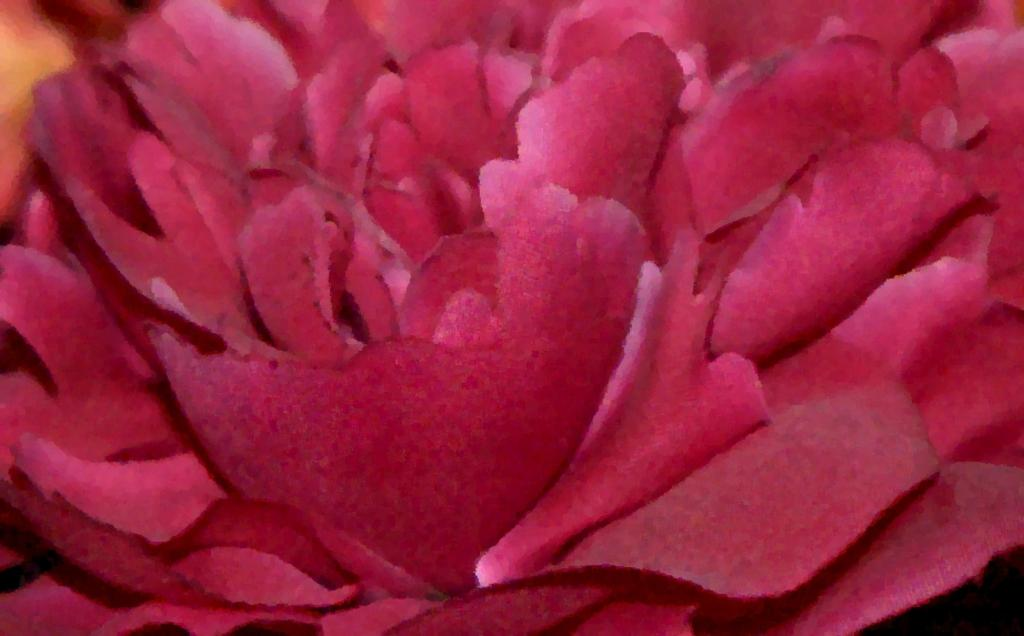What type of flower is present in the image? There is a rose-colored flower in the image. What type of polish is being applied to the grandfather's shoes in the image? There is no grandfather or shoes present in the image; it only features a rose-colored flower. 